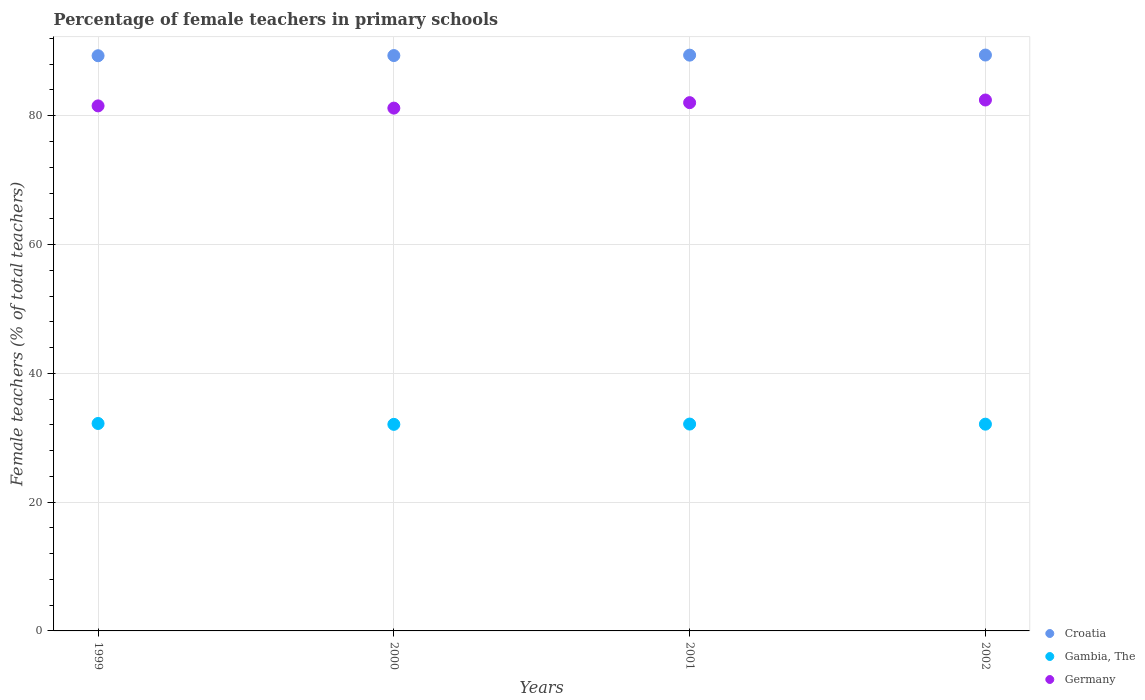What is the percentage of female teachers in Germany in 1999?
Offer a terse response. 81.53. Across all years, what is the maximum percentage of female teachers in Croatia?
Ensure brevity in your answer.  89.42. Across all years, what is the minimum percentage of female teachers in Croatia?
Your answer should be compact. 89.32. What is the total percentage of female teachers in Gambia, The in the graph?
Offer a terse response. 128.51. What is the difference between the percentage of female teachers in Gambia, The in 1999 and that in 2000?
Your answer should be compact. 0.14. What is the difference between the percentage of female teachers in Germany in 2002 and the percentage of female teachers in Gambia, The in 2000?
Provide a succinct answer. 50.37. What is the average percentage of female teachers in Gambia, The per year?
Give a very brief answer. 32.13. In the year 2002, what is the difference between the percentage of female teachers in Croatia and percentage of female teachers in Germany?
Your answer should be very brief. 6.98. In how many years, is the percentage of female teachers in Croatia greater than 4 %?
Ensure brevity in your answer.  4. What is the ratio of the percentage of female teachers in Gambia, The in 1999 to that in 2001?
Offer a very short reply. 1. Is the percentage of female teachers in Croatia in 1999 less than that in 2000?
Your answer should be very brief. Yes. Is the difference between the percentage of female teachers in Croatia in 2001 and 2002 greater than the difference between the percentage of female teachers in Germany in 2001 and 2002?
Your answer should be very brief. Yes. What is the difference between the highest and the second highest percentage of female teachers in Croatia?
Provide a short and direct response. 0.02. What is the difference between the highest and the lowest percentage of female teachers in Croatia?
Your response must be concise. 0.11. In how many years, is the percentage of female teachers in Gambia, The greater than the average percentage of female teachers in Gambia, The taken over all years?
Provide a short and direct response. 1. Is it the case that in every year, the sum of the percentage of female teachers in Gambia, The and percentage of female teachers in Germany  is greater than the percentage of female teachers in Croatia?
Provide a short and direct response. Yes. Does the percentage of female teachers in Gambia, The monotonically increase over the years?
Your answer should be compact. No. Is the percentage of female teachers in Germany strictly greater than the percentage of female teachers in Gambia, The over the years?
Offer a very short reply. Yes. How many years are there in the graph?
Ensure brevity in your answer.  4. What is the difference between two consecutive major ticks on the Y-axis?
Provide a succinct answer. 20. How many legend labels are there?
Ensure brevity in your answer.  3. How are the legend labels stacked?
Make the answer very short. Vertical. What is the title of the graph?
Make the answer very short. Percentage of female teachers in primary schools. Does "Philippines" appear as one of the legend labels in the graph?
Make the answer very short. No. What is the label or title of the X-axis?
Your answer should be very brief. Years. What is the label or title of the Y-axis?
Offer a terse response. Female teachers (% of total teachers). What is the Female teachers (% of total teachers) of Croatia in 1999?
Ensure brevity in your answer.  89.32. What is the Female teachers (% of total teachers) in Gambia, The in 1999?
Ensure brevity in your answer.  32.21. What is the Female teachers (% of total teachers) in Germany in 1999?
Ensure brevity in your answer.  81.53. What is the Female teachers (% of total teachers) in Croatia in 2000?
Your answer should be compact. 89.34. What is the Female teachers (% of total teachers) of Gambia, The in 2000?
Give a very brief answer. 32.08. What is the Female teachers (% of total teachers) in Germany in 2000?
Ensure brevity in your answer.  81.18. What is the Female teachers (% of total teachers) of Croatia in 2001?
Keep it short and to the point. 89.41. What is the Female teachers (% of total teachers) in Gambia, The in 2001?
Offer a terse response. 32.12. What is the Female teachers (% of total teachers) in Germany in 2001?
Your response must be concise. 82.03. What is the Female teachers (% of total teachers) in Croatia in 2002?
Your response must be concise. 89.42. What is the Female teachers (% of total teachers) of Gambia, The in 2002?
Make the answer very short. 32.11. What is the Female teachers (% of total teachers) in Germany in 2002?
Give a very brief answer. 82.44. Across all years, what is the maximum Female teachers (% of total teachers) of Croatia?
Your response must be concise. 89.42. Across all years, what is the maximum Female teachers (% of total teachers) in Gambia, The?
Offer a terse response. 32.21. Across all years, what is the maximum Female teachers (% of total teachers) in Germany?
Your answer should be very brief. 82.44. Across all years, what is the minimum Female teachers (% of total teachers) in Croatia?
Make the answer very short. 89.32. Across all years, what is the minimum Female teachers (% of total teachers) of Gambia, The?
Your answer should be compact. 32.08. Across all years, what is the minimum Female teachers (% of total teachers) of Germany?
Provide a short and direct response. 81.18. What is the total Female teachers (% of total teachers) of Croatia in the graph?
Ensure brevity in your answer.  357.49. What is the total Female teachers (% of total teachers) of Gambia, The in the graph?
Provide a short and direct response. 128.51. What is the total Female teachers (% of total teachers) in Germany in the graph?
Give a very brief answer. 327.18. What is the difference between the Female teachers (% of total teachers) in Croatia in 1999 and that in 2000?
Provide a short and direct response. -0.03. What is the difference between the Female teachers (% of total teachers) of Gambia, The in 1999 and that in 2000?
Ensure brevity in your answer.  0.14. What is the difference between the Female teachers (% of total teachers) of Germany in 1999 and that in 2000?
Offer a very short reply. 0.35. What is the difference between the Female teachers (% of total teachers) of Croatia in 1999 and that in 2001?
Your response must be concise. -0.09. What is the difference between the Female teachers (% of total teachers) in Gambia, The in 1999 and that in 2001?
Your answer should be compact. 0.09. What is the difference between the Female teachers (% of total teachers) of Germany in 1999 and that in 2001?
Keep it short and to the point. -0.5. What is the difference between the Female teachers (% of total teachers) in Croatia in 1999 and that in 2002?
Give a very brief answer. -0.11. What is the difference between the Female teachers (% of total teachers) in Gambia, The in 1999 and that in 2002?
Provide a succinct answer. 0.11. What is the difference between the Female teachers (% of total teachers) in Germany in 1999 and that in 2002?
Provide a short and direct response. -0.91. What is the difference between the Female teachers (% of total teachers) of Croatia in 2000 and that in 2001?
Offer a very short reply. -0.06. What is the difference between the Female teachers (% of total teachers) in Gambia, The in 2000 and that in 2001?
Offer a terse response. -0.05. What is the difference between the Female teachers (% of total teachers) in Germany in 2000 and that in 2001?
Your answer should be very brief. -0.85. What is the difference between the Female teachers (% of total teachers) in Croatia in 2000 and that in 2002?
Make the answer very short. -0.08. What is the difference between the Female teachers (% of total teachers) of Gambia, The in 2000 and that in 2002?
Your answer should be compact. -0.03. What is the difference between the Female teachers (% of total teachers) of Germany in 2000 and that in 2002?
Give a very brief answer. -1.26. What is the difference between the Female teachers (% of total teachers) of Croatia in 2001 and that in 2002?
Offer a very short reply. -0.02. What is the difference between the Female teachers (% of total teachers) of Gambia, The in 2001 and that in 2002?
Keep it short and to the point. 0.02. What is the difference between the Female teachers (% of total teachers) of Germany in 2001 and that in 2002?
Keep it short and to the point. -0.41. What is the difference between the Female teachers (% of total teachers) of Croatia in 1999 and the Female teachers (% of total teachers) of Gambia, The in 2000?
Offer a very short reply. 57.24. What is the difference between the Female teachers (% of total teachers) in Croatia in 1999 and the Female teachers (% of total teachers) in Germany in 2000?
Make the answer very short. 8.13. What is the difference between the Female teachers (% of total teachers) of Gambia, The in 1999 and the Female teachers (% of total teachers) of Germany in 2000?
Offer a terse response. -48.97. What is the difference between the Female teachers (% of total teachers) in Croatia in 1999 and the Female teachers (% of total teachers) in Gambia, The in 2001?
Provide a short and direct response. 57.2. What is the difference between the Female teachers (% of total teachers) of Croatia in 1999 and the Female teachers (% of total teachers) of Germany in 2001?
Your answer should be compact. 7.28. What is the difference between the Female teachers (% of total teachers) in Gambia, The in 1999 and the Female teachers (% of total teachers) in Germany in 2001?
Your answer should be compact. -49.82. What is the difference between the Female teachers (% of total teachers) in Croatia in 1999 and the Female teachers (% of total teachers) in Gambia, The in 2002?
Your answer should be compact. 57.21. What is the difference between the Female teachers (% of total teachers) in Croatia in 1999 and the Female teachers (% of total teachers) in Germany in 2002?
Offer a very short reply. 6.88. What is the difference between the Female teachers (% of total teachers) in Gambia, The in 1999 and the Female teachers (% of total teachers) in Germany in 2002?
Give a very brief answer. -50.23. What is the difference between the Female teachers (% of total teachers) of Croatia in 2000 and the Female teachers (% of total teachers) of Gambia, The in 2001?
Provide a short and direct response. 57.22. What is the difference between the Female teachers (% of total teachers) of Croatia in 2000 and the Female teachers (% of total teachers) of Germany in 2001?
Keep it short and to the point. 7.31. What is the difference between the Female teachers (% of total teachers) of Gambia, The in 2000 and the Female teachers (% of total teachers) of Germany in 2001?
Your answer should be very brief. -49.96. What is the difference between the Female teachers (% of total teachers) in Croatia in 2000 and the Female teachers (% of total teachers) in Gambia, The in 2002?
Your answer should be compact. 57.24. What is the difference between the Female teachers (% of total teachers) in Croatia in 2000 and the Female teachers (% of total teachers) in Germany in 2002?
Offer a very short reply. 6.9. What is the difference between the Female teachers (% of total teachers) of Gambia, The in 2000 and the Female teachers (% of total teachers) of Germany in 2002?
Your answer should be very brief. -50.37. What is the difference between the Female teachers (% of total teachers) in Croatia in 2001 and the Female teachers (% of total teachers) in Gambia, The in 2002?
Make the answer very short. 57.3. What is the difference between the Female teachers (% of total teachers) in Croatia in 2001 and the Female teachers (% of total teachers) in Germany in 2002?
Give a very brief answer. 6.97. What is the difference between the Female teachers (% of total teachers) in Gambia, The in 2001 and the Female teachers (% of total teachers) in Germany in 2002?
Offer a very short reply. -50.32. What is the average Female teachers (% of total teachers) in Croatia per year?
Provide a short and direct response. 89.37. What is the average Female teachers (% of total teachers) in Gambia, The per year?
Provide a succinct answer. 32.13. What is the average Female teachers (% of total teachers) in Germany per year?
Provide a succinct answer. 81.8. In the year 1999, what is the difference between the Female teachers (% of total teachers) of Croatia and Female teachers (% of total teachers) of Gambia, The?
Provide a succinct answer. 57.1. In the year 1999, what is the difference between the Female teachers (% of total teachers) in Croatia and Female teachers (% of total teachers) in Germany?
Provide a succinct answer. 7.79. In the year 1999, what is the difference between the Female teachers (% of total teachers) in Gambia, The and Female teachers (% of total teachers) in Germany?
Offer a terse response. -49.32. In the year 2000, what is the difference between the Female teachers (% of total teachers) in Croatia and Female teachers (% of total teachers) in Gambia, The?
Your answer should be very brief. 57.27. In the year 2000, what is the difference between the Female teachers (% of total teachers) in Croatia and Female teachers (% of total teachers) in Germany?
Make the answer very short. 8.16. In the year 2000, what is the difference between the Female teachers (% of total teachers) of Gambia, The and Female teachers (% of total teachers) of Germany?
Give a very brief answer. -49.11. In the year 2001, what is the difference between the Female teachers (% of total teachers) in Croatia and Female teachers (% of total teachers) in Gambia, The?
Your answer should be very brief. 57.29. In the year 2001, what is the difference between the Female teachers (% of total teachers) of Croatia and Female teachers (% of total teachers) of Germany?
Offer a terse response. 7.38. In the year 2001, what is the difference between the Female teachers (% of total teachers) in Gambia, The and Female teachers (% of total teachers) in Germany?
Offer a terse response. -49.91. In the year 2002, what is the difference between the Female teachers (% of total teachers) of Croatia and Female teachers (% of total teachers) of Gambia, The?
Keep it short and to the point. 57.32. In the year 2002, what is the difference between the Female teachers (% of total teachers) of Croatia and Female teachers (% of total teachers) of Germany?
Offer a very short reply. 6.98. In the year 2002, what is the difference between the Female teachers (% of total teachers) of Gambia, The and Female teachers (% of total teachers) of Germany?
Ensure brevity in your answer.  -50.34. What is the ratio of the Female teachers (% of total teachers) in Gambia, The in 1999 to that in 2000?
Ensure brevity in your answer.  1. What is the ratio of the Female teachers (% of total teachers) in Gambia, The in 1999 to that in 2001?
Ensure brevity in your answer.  1. What is the ratio of the Female teachers (% of total teachers) in Croatia in 1999 to that in 2002?
Your response must be concise. 1. What is the ratio of the Female teachers (% of total teachers) in Gambia, The in 1999 to that in 2002?
Offer a terse response. 1. What is the ratio of the Female teachers (% of total teachers) of Germany in 1999 to that in 2002?
Provide a short and direct response. 0.99. What is the ratio of the Female teachers (% of total teachers) of Gambia, The in 2000 to that in 2002?
Give a very brief answer. 1. What is the ratio of the Female teachers (% of total teachers) in Germany in 2000 to that in 2002?
Your answer should be compact. 0.98. What is the ratio of the Female teachers (% of total teachers) in Gambia, The in 2001 to that in 2002?
Make the answer very short. 1. What is the ratio of the Female teachers (% of total teachers) of Germany in 2001 to that in 2002?
Make the answer very short. 0.99. What is the difference between the highest and the second highest Female teachers (% of total teachers) in Croatia?
Provide a short and direct response. 0.02. What is the difference between the highest and the second highest Female teachers (% of total teachers) of Gambia, The?
Give a very brief answer. 0.09. What is the difference between the highest and the second highest Female teachers (% of total teachers) in Germany?
Offer a terse response. 0.41. What is the difference between the highest and the lowest Female teachers (% of total teachers) of Croatia?
Provide a succinct answer. 0.11. What is the difference between the highest and the lowest Female teachers (% of total teachers) in Gambia, The?
Provide a short and direct response. 0.14. What is the difference between the highest and the lowest Female teachers (% of total teachers) of Germany?
Make the answer very short. 1.26. 